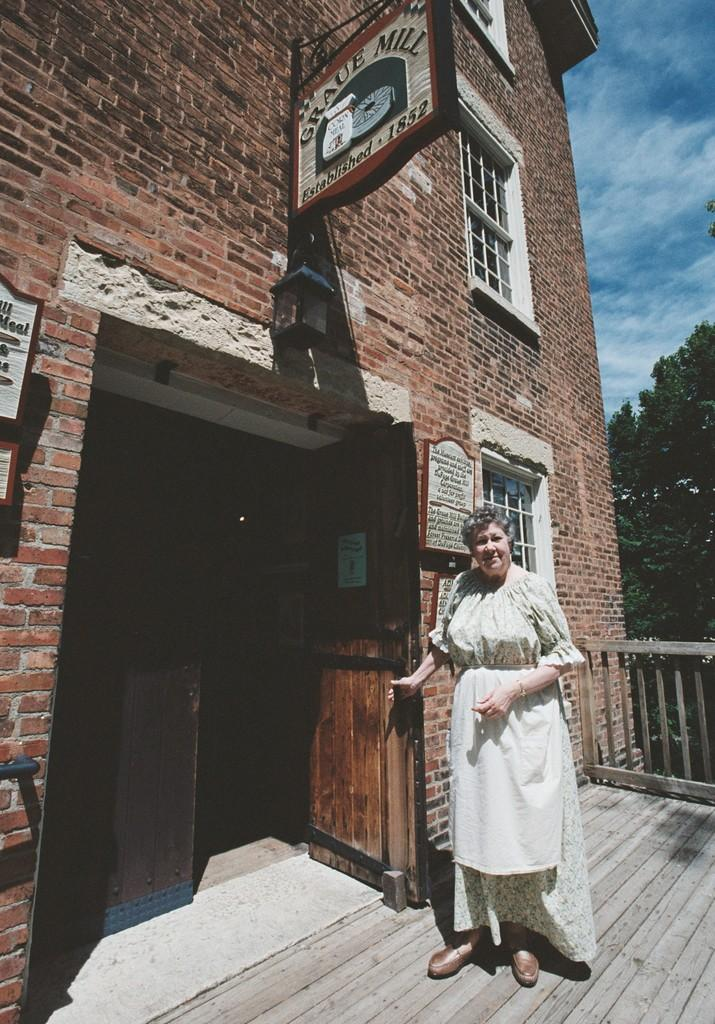What is the woman doing in the image? The woman is standing on the floor in the image. What type of structure can be seen in the image? There is a building in the image. Can you describe any specific features of the building? There is a door, boards, windows, and a fence visible in the image. What type of natural elements are present in the image? There are trees and the sky visible in the image. What color is the crayon being used by the woman in the image? There is no crayon present in the image. How many trays can be seen on the floor in the image? There are no trays visible on the floor in the image. 